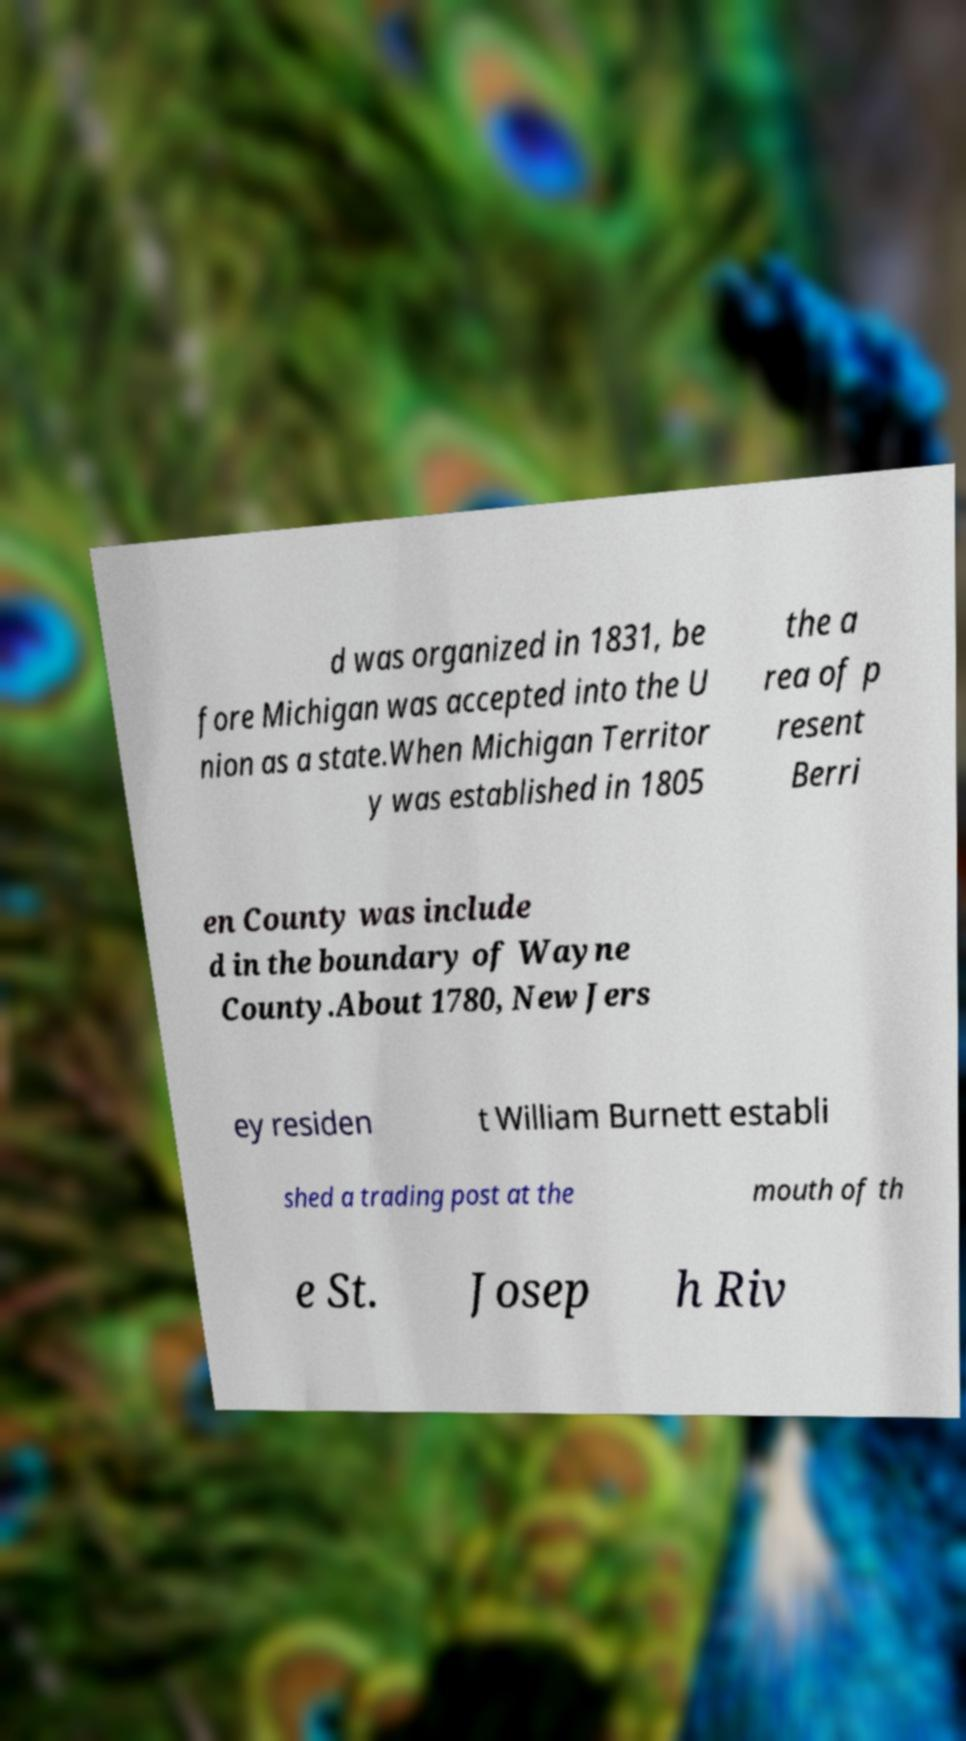Please read and relay the text visible in this image. What does it say? d was organized in 1831, be fore Michigan was accepted into the U nion as a state.When Michigan Territor y was established in 1805 the a rea of p resent Berri en County was include d in the boundary of Wayne County.About 1780, New Jers ey residen t William Burnett establi shed a trading post at the mouth of th e St. Josep h Riv 